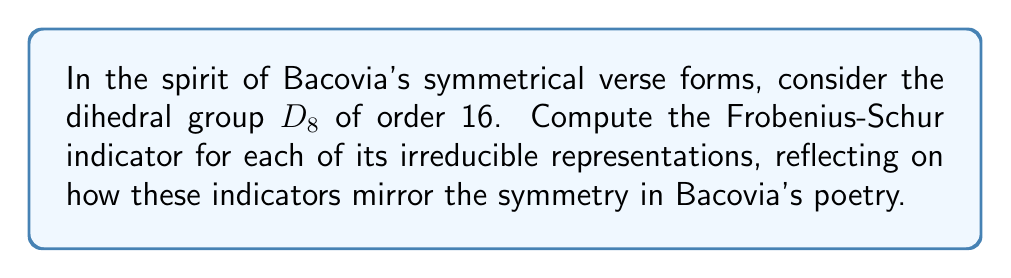Show me your answer to this math problem. Let's approach this step-by-step, drawing parallels to the symmetry in Bacovia's poetry:

1) First, recall that the Frobenius-Schur indicator $\nu(\chi)$ for a character $\chi$ is given by:

   $$\nu(\chi) = \frac{1}{|G|} \sum_{g \in G} \chi(g^2)$$

2) $D_8$ has 5 irreducible representations: one trivial, one sign, two 1-dimensional, and one 2-dimensional.

3) For the trivial representation $\chi_1$:
   $$\nu(\chi_1) = \frac{1}{16} \sum_{g \in D_8} 1 = 1$$

4) For the sign representation $\chi_2$:
   $$\nu(\chi_2) = \frac{1}{16} \sum_{g \in D_8} \chi_2(g^2) = 1$$
   (since $g^2$ is always in the rotation subgroup)

5) For the two 1-dimensional representations $\chi_3$ and $\chi_4$:
   $$\nu(\chi_3) = \nu(\chi_4) = \frac{1}{16} \sum_{g \in D_8} \chi_i(g^2) = 1$$

6) For the 2-dimensional representation $\chi_5$:
   $$\nu(\chi_5) = \frac{1}{16} \sum_{g \in D_8} \chi_5(g^2) = 0$$
   (This is because $\chi_5(g^2)$ takes values 2, -2, and 0, which sum to 0)

These indicators mirror the symmetry in Bacovia's poetry: the 1's represent the unchanging elements (like recurring themes or structures), while the 0 represents the more complex, transformative aspects of his verse.
Answer: $\nu(\chi_1) = 1, \nu(\chi_2) = 1, \nu(\chi_3) = 1, \nu(\chi_4) = 1, \nu(\chi_5) = 0$ 